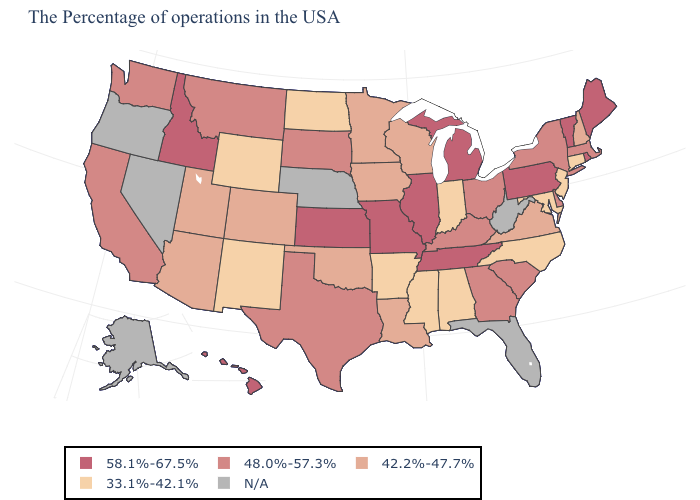What is the value of Missouri?
Quick response, please. 58.1%-67.5%. What is the value of Maryland?
Write a very short answer. 33.1%-42.1%. Does Connecticut have the lowest value in the USA?
Short answer required. Yes. Does Massachusetts have the lowest value in the USA?
Write a very short answer. No. Name the states that have a value in the range 33.1%-42.1%?
Write a very short answer. Connecticut, New Jersey, Maryland, North Carolina, Indiana, Alabama, Mississippi, Arkansas, North Dakota, Wyoming, New Mexico. What is the value of North Dakota?
Quick response, please. 33.1%-42.1%. Which states have the lowest value in the USA?
Be succinct. Connecticut, New Jersey, Maryland, North Carolina, Indiana, Alabama, Mississippi, Arkansas, North Dakota, Wyoming, New Mexico. Does the map have missing data?
Short answer required. Yes. Name the states that have a value in the range 33.1%-42.1%?
Write a very short answer. Connecticut, New Jersey, Maryland, North Carolina, Indiana, Alabama, Mississippi, Arkansas, North Dakota, Wyoming, New Mexico. What is the value of West Virginia?
Give a very brief answer. N/A. Which states have the lowest value in the USA?
Keep it brief. Connecticut, New Jersey, Maryland, North Carolina, Indiana, Alabama, Mississippi, Arkansas, North Dakota, Wyoming, New Mexico. Which states have the lowest value in the Northeast?
Answer briefly. Connecticut, New Jersey. 